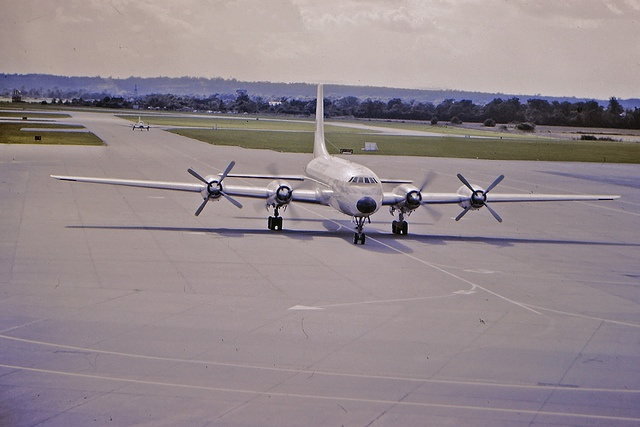Describe the objects in this image and their specific colors. I can see airplane in gray, darkgray, lightgray, and black tones, airplane in gray, darkgray, lightgray, and black tones, and airplane in gray, darkgray, and black tones in this image. 